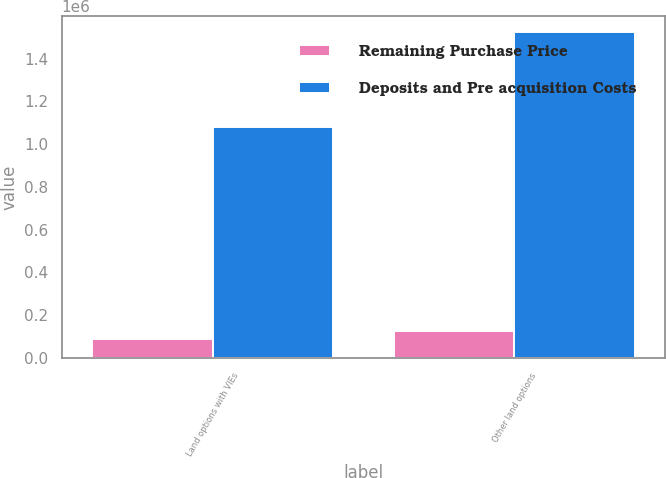<chart> <loc_0><loc_0><loc_500><loc_500><stacked_bar_chart><ecel><fcel>Land options with VIEs<fcel>Other land options<nl><fcel>Remaining Purchase Price<fcel>90717<fcel>127851<nl><fcel>Deposits and Pre acquisition Costs<fcel>1.07951e+06<fcel>1.5229e+06<nl></chart> 